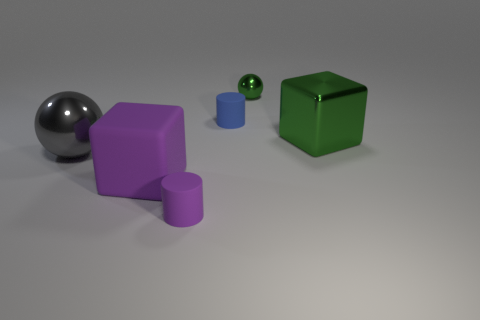What material is the cylinder that is the same color as the large rubber cube?
Make the answer very short. Rubber. Is the size of the sphere behind the blue thing the same as the gray metal sphere?
Give a very brief answer. No. What material is the large thing that is both to the right of the big gray shiny sphere and to the left of the tiny blue matte object?
Your answer should be very brief. Rubber. Is the number of spheres to the right of the small purple matte cylinder greater than the number of small cyan rubber spheres?
Make the answer very short. Yes. Is there a cyan sphere?
Keep it short and to the point. No. How many blue matte cylinders are the same size as the green metal ball?
Provide a short and direct response. 1. Are there more green metallic things that are right of the large purple matte thing than big things that are on the left side of the large gray object?
Make the answer very short. Yes. What material is the gray sphere that is the same size as the metal cube?
Keep it short and to the point. Metal. What is the shape of the gray object?
Make the answer very short. Sphere. How many blue things are tiny rubber cylinders or shiny cubes?
Provide a short and direct response. 1. 